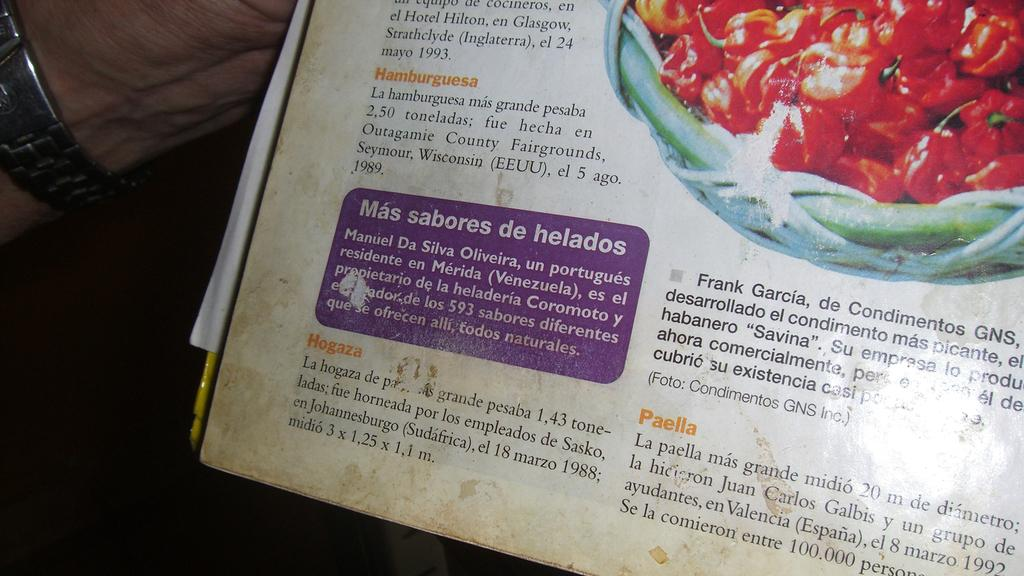Provide a one-sentence caption for the provided image. A menu shows items in Spanish, one being Hamburguesa. 